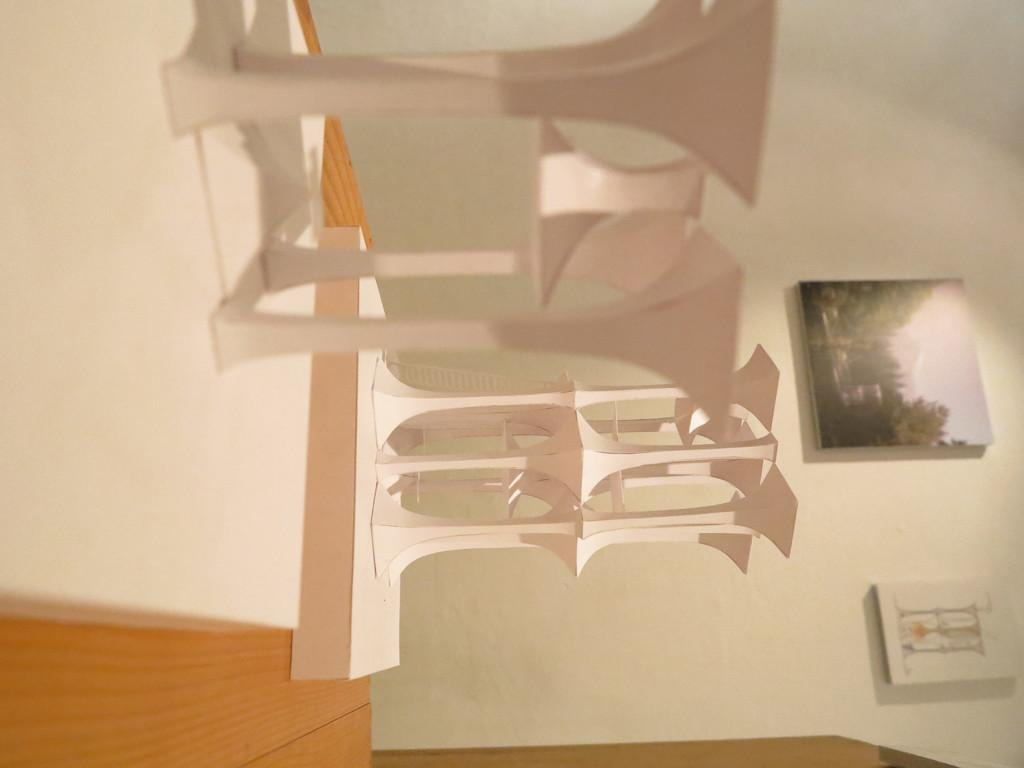What type of surface can be seen in the image? There is a wooden table in the image. What is placed on the wooden table? There are objects on the wooden table in the image. What can be seen on the wall in the image? There are photo frames on a wall in the image. What type of vase is used to cause the objects on the table to levitate in the image? There is no vase or levitation present in the image; the objects on the table are resting on the wooden surface. 